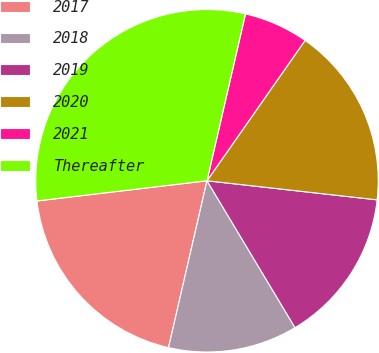Convert chart to OTSL. <chart><loc_0><loc_0><loc_500><loc_500><pie_chart><fcel>2017<fcel>2018<fcel>2019<fcel>2020<fcel>2021<fcel>Thereafter<nl><fcel>19.51%<fcel>12.2%<fcel>14.63%<fcel>17.07%<fcel>6.1%<fcel>30.49%<nl></chart> 